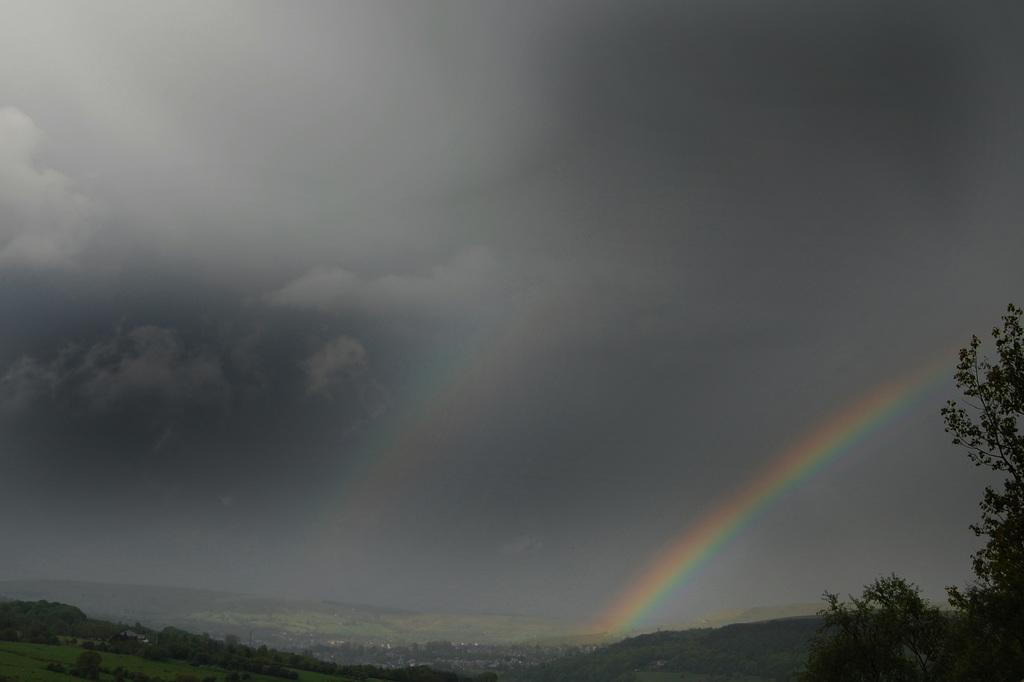What type of vegetation can be seen in the image? There are trees in the image. How would you describe the sky in the image? The sky is black and cloudy in the image. What additional atmospheric feature can be seen in the image? There are rainbows visible in the image. Can you tell me how many ants are crawling on the record in the image? There is no record or ants present in the image. What type of medical facility is visible in the image? There is no hospital or any medical facility present in the image. 